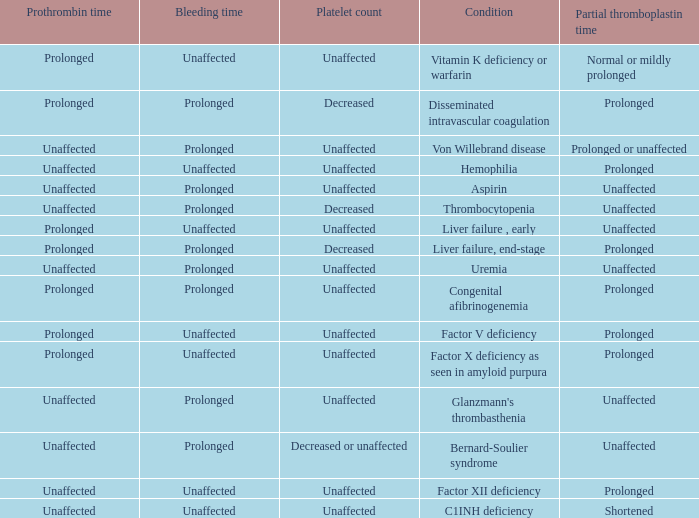Which Bleeding has a Condition of congenital afibrinogenemia? Prolonged. 